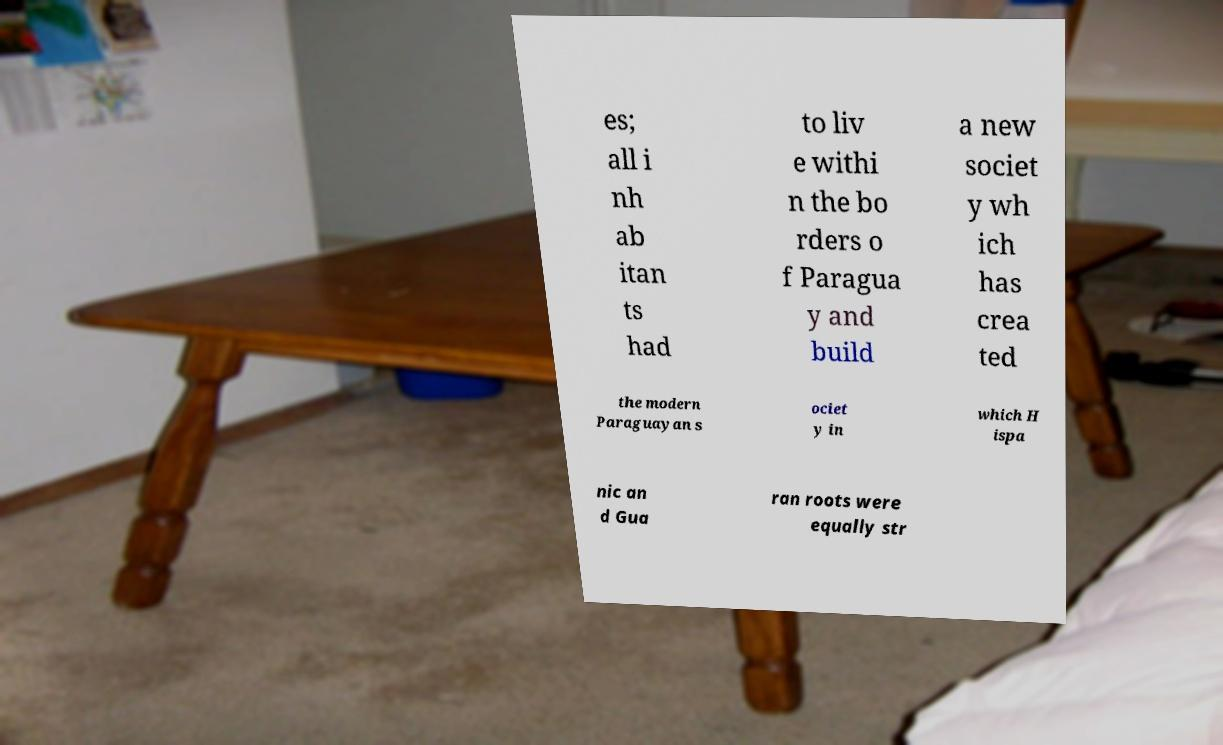Can you accurately transcribe the text from the provided image for me? es; all i nh ab itan ts had to liv e withi n the bo rders o f Paragua y and build a new societ y wh ich has crea ted the modern Paraguayan s ociet y in which H ispa nic an d Gua ran roots were equally str 